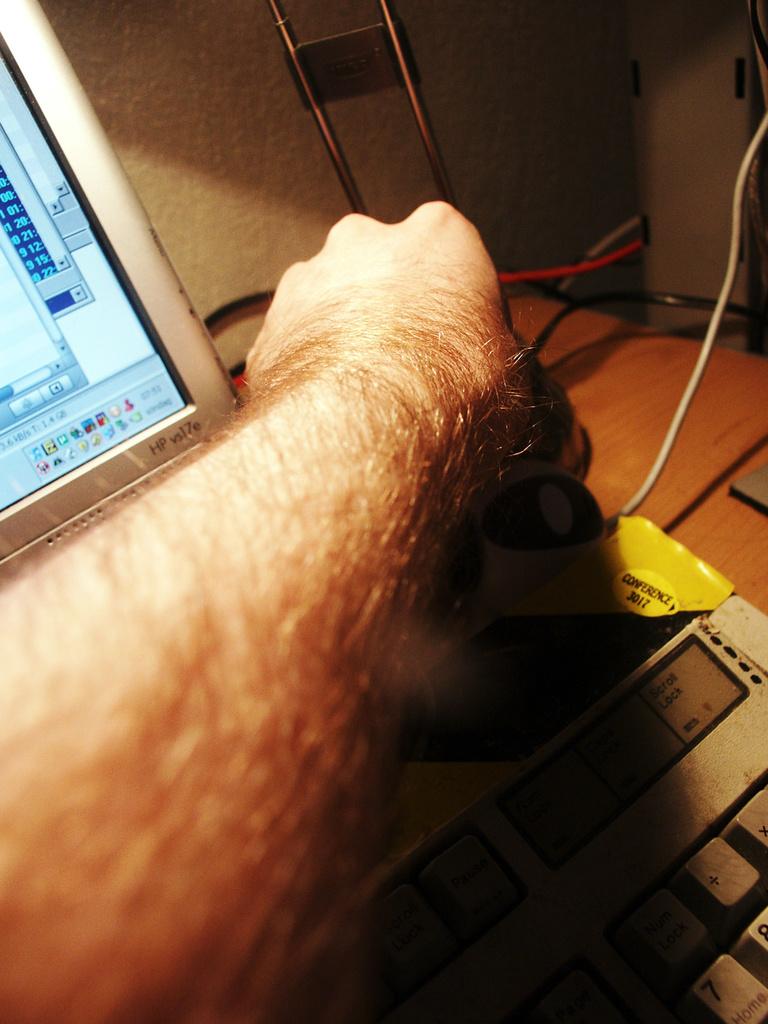What brand is this computer?
Ensure brevity in your answer.  Hp. 